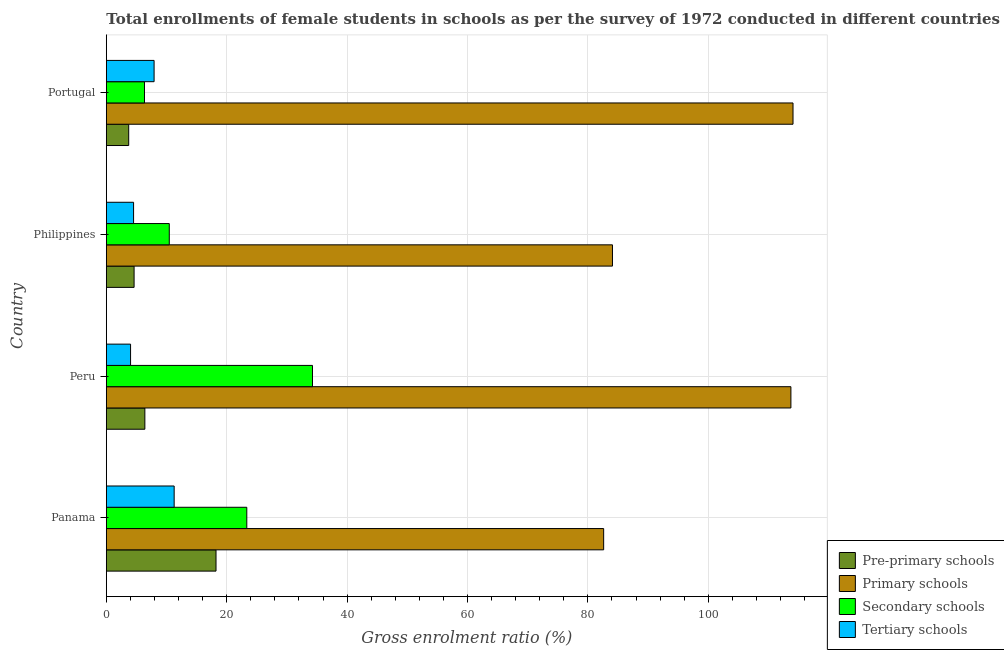Are the number of bars per tick equal to the number of legend labels?
Your answer should be compact. Yes. What is the gross enrolment ratio(female) in pre-primary schools in Philippines?
Make the answer very short. 4.61. Across all countries, what is the maximum gross enrolment ratio(female) in primary schools?
Your response must be concise. 114.07. Across all countries, what is the minimum gross enrolment ratio(female) in secondary schools?
Your answer should be very brief. 6.34. In which country was the gross enrolment ratio(female) in pre-primary schools maximum?
Provide a short and direct response. Panama. In which country was the gross enrolment ratio(female) in secondary schools minimum?
Keep it short and to the point. Portugal. What is the total gross enrolment ratio(female) in secondary schools in the graph?
Give a very brief answer. 74.37. What is the difference between the gross enrolment ratio(female) in secondary schools in Peru and that in Philippines?
Offer a terse response. 23.79. What is the difference between the gross enrolment ratio(female) in pre-primary schools in Philippines and the gross enrolment ratio(female) in secondary schools in Portugal?
Ensure brevity in your answer.  -1.73. What is the average gross enrolment ratio(female) in tertiary schools per country?
Your response must be concise. 6.94. What is the difference between the gross enrolment ratio(female) in pre-primary schools and gross enrolment ratio(female) in tertiary schools in Panama?
Give a very brief answer. 6.95. In how many countries, is the gross enrolment ratio(female) in secondary schools greater than 12 %?
Provide a succinct answer. 2. What is the ratio of the gross enrolment ratio(female) in primary schools in Peru to that in Portugal?
Provide a succinct answer. 1. Is the difference between the gross enrolment ratio(female) in pre-primary schools in Peru and Portugal greater than the difference between the gross enrolment ratio(female) in tertiary schools in Peru and Portugal?
Your answer should be very brief. Yes. What is the difference between the highest and the second highest gross enrolment ratio(female) in tertiary schools?
Offer a terse response. 3.33. What is the difference between the highest and the lowest gross enrolment ratio(female) in tertiary schools?
Offer a terse response. 7.24. What does the 4th bar from the top in Portugal represents?
Offer a very short reply. Pre-primary schools. What does the 2nd bar from the bottom in Peru represents?
Your answer should be very brief. Primary schools. How many bars are there?
Keep it short and to the point. 16. What is the difference between two consecutive major ticks on the X-axis?
Your answer should be very brief. 20. Are the values on the major ticks of X-axis written in scientific E-notation?
Your response must be concise. No. Does the graph contain grids?
Ensure brevity in your answer.  Yes. What is the title of the graph?
Your answer should be very brief. Total enrollments of female students in schools as per the survey of 1972 conducted in different countries. Does "Greece" appear as one of the legend labels in the graph?
Provide a succinct answer. No. What is the label or title of the Y-axis?
Offer a terse response. Country. What is the Gross enrolment ratio (%) of Pre-primary schools in Panama?
Offer a very short reply. 18.22. What is the Gross enrolment ratio (%) in Primary schools in Panama?
Your answer should be compact. 82.62. What is the Gross enrolment ratio (%) in Secondary schools in Panama?
Give a very brief answer. 23.33. What is the Gross enrolment ratio (%) of Tertiary schools in Panama?
Offer a very short reply. 11.27. What is the Gross enrolment ratio (%) in Pre-primary schools in Peru?
Your response must be concise. 6.4. What is the Gross enrolment ratio (%) in Primary schools in Peru?
Make the answer very short. 113.72. What is the Gross enrolment ratio (%) of Secondary schools in Peru?
Offer a very short reply. 34.25. What is the Gross enrolment ratio (%) in Tertiary schools in Peru?
Provide a short and direct response. 4.02. What is the Gross enrolment ratio (%) in Pre-primary schools in Philippines?
Keep it short and to the point. 4.61. What is the Gross enrolment ratio (%) in Primary schools in Philippines?
Give a very brief answer. 84.08. What is the Gross enrolment ratio (%) in Secondary schools in Philippines?
Make the answer very short. 10.46. What is the Gross enrolment ratio (%) in Tertiary schools in Philippines?
Your response must be concise. 4.53. What is the Gross enrolment ratio (%) in Pre-primary schools in Portugal?
Make the answer very short. 3.72. What is the Gross enrolment ratio (%) in Primary schools in Portugal?
Keep it short and to the point. 114.07. What is the Gross enrolment ratio (%) of Secondary schools in Portugal?
Your answer should be very brief. 6.34. What is the Gross enrolment ratio (%) of Tertiary schools in Portugal?
Provide a succinct answer. 7.93. Across all countries, what is the maximum Gross enrolment ratio (%) in Pre-primary schools?
Offer a terse response. 18.22. Across all countries, what is the maximum Gross enrolment ratio (%) in Primary schools?
Ensure brevity in your answer.  114.07. Across all countries, what is the maximum Gross enrolment ratio (%) in Secondary schools?
Ensure brevity in your answer.  34.25. Across all countries, what is the maximum Gross enrolment ratio (%) in Tertiary schools?
Your answer should be very brief. 11.27. Across all countries, what is the minimum Gross enrolment ratio (%) in Pre-primary schools?
Your answer should be very brief. 3.72. Across all countries, what is the minimum Gross enrolment ratio (%) in Primary schools?
Give a very brief answer. 82.62. Across all countries, what is the minimum Gross enrolment ratio (%) of Secondary schools?
Your answer should be compact. 6.34. Across all countries, what is the minimum Gross enrolment ratio (%) of Tertiary schools?
Your answer should be compact. 4.02. What is the total Gross enrolment ratio (%) of Pre-primary schools in the graph?
Offer a very short reply. 32.95. What is the total Gross enrolment ratio (%) in Primary schools in the graph?
Offer a very short reply. 394.49. What is the total Gross enrolment ratio (%) of Secondary schools in the graph?
Keep it short and to the point. 74.37. What is the total Gross enrolment ratio (%) of Tertiary schools in the graph?
Offer a terse response. 27.75. What is the difference between the Gross enrolment ratio (%) of Pre-primary schools in Panama and that in Peru?
Make the answer very short. 11.82. What is the difference between the Gross enrolment ratio (%) of Primary schools in Panama and that in Peru?
Give a very brief answer. -31.11. What is the difference between the Gross enrolment ratio (%) in Secondary schools in Panama and that in Peru?
Your response must be concise. -10.91. What is the difference between the Gross enrolment ratio (%) of Tertiary schools in Panama and that in Peru?
Your answer should be compact. 7.24. What is the difference between the Gross enrolment ratio (%) in Pre-primary schools in Panama and that in Philippines?
Make the answer very short. 13.61. What is the difference between the Gross enrolment ratio (%) of Primary schools in Panama and that in Philippines?
Make the answer very short. -1.46. What is the difference between the Gross enrolment ratio (%) of Secondary schools in Panama and that in Philippines?
Keep it short and to the point. 12.88. What is the difference between the Gross enrolment ratio (%) of Tertiary schools in Panama and that in Philippines?
Your response must be concise. 6.74. What is the difference between the Gross enrolment ratio (%) of Pre-primary schools in Panama and that in Portugal?
Your response must be concise. 14.5. What is the difference between the Gross enrolment ratio (%) of Primary schools in Panama and that in Portugal?
Make the answer very short. -31.46. What is the difference between the Gross enrolment ratio (%) of Secondary schools in Panama and that in Portugal?
Your response must be concise. 16.99. What is the difference between the Gross enrolment ratio (%) in Tertiary schools in Panama and that in Portugal?
Your answer should be very brief. 3.33. What is the difference between the Gross enrolment ratio (%) in Pre-primary schools in Peru and that in Philippines?
Provide a short and direct response. 1.79. What is the difference between the Gross enrolment ratio (%) of Primary schools in Peru and that in Philippines?
Provide a short and direct response. 29.64. What is the difference between the Gross enrolment ratio (%) of Secondary schools in Peru and that in Philippines?
Offer a very short reply. 23.79. What is the difference between the Gross enrolment ratio (%) in Tertiary schools in Peru and that in Philippines?
Provide a succinct answer. -0.5. What is the difference between the Gross enrolment ratio (%) in Pre-primary schools in Peru and that in Portugal?
Keep it short and to the point. 2.68. What is the difference between the Gross enrolment ratio (%) of Primary schools in Peru and that in Portugal?
Offer a terse response. -0.35. What is the difference between the Gross enrolment ratio (%) in Secondary schools in Peru and that in Portugal?
Keep it short and to the point. 27.91. What is the difference between the Gross enrolment ratio (%) in Tertiary schools in Peru and that in Portugal?
Your answer should be compact. -3.91. What is the difference between the Gross enrolment ratio (%) of Pre-primary schools in Philippines and that in Portugal?
Your response must be concise. 0.89. What is the difference between the Gross enrolment ratio (%) of Primary schools in Philippines and that in Portugal?
Provide a short and direct response. -29.99. What is the difference between the Gross enrolment ratio (%) in Secondary schools in Philippines and that in Portugal?
Your answer should be compact. 4.12. What is the difference between the Gross enrolment ratio (%) of Tertiary schools in Philippines and that in Portugal?
Offer a terse response. -3.41. What is the difference between the Gross enrolment ratio (%) of Pre-primary schools in Panama and the Gross enrolment ratio (%) of Primary schools in Peru?
Your answer should be very brief. -95.5. What is the difference between the Gross enrolment ratio (%) of Pre-primary schools in Panama and the Gross enrolment ratio (%) of Secondary schools in Peru?
Your answer should be compact. -16.02. What is the difference between the Gross enrolment ratio (%) of Pre-primary schools in Panama and the Gross enrolment ratio (%) of Tertiary schools in Peru?
Ensure brevity in your answer.  14.2. What is the difference between the Gross enrolment ratio (%) of Primary schools in Panama and the Gross enrolment ratio (%) of Secondary schools in Peru?
Keep it short and to the point. 48.37. What is the difference between the Gross enrolment ratio (%) in Primary schools in Panama and the Gross enrolment ratio (%) in Tertiary schools in Peru?
Provide a succinct answer. 78.59. What is the difference between the Gross enrolment ratio (%) in Secondary schools in Panama and the Gross enrolment ratio (%) in Tertiary schools in Peru?
Give a very brief answer. 19.31. What is the difference between the Gross enrolment ratio (%) in Pre-primary schools in Panama and the Gross enrolment ratio (%) in Primary schools in Philippines?
Your response must be concise. -65.86. What is the difference between the Gross enrolment ratio (%) in Pre-primary schools in Panama and the Gross enrolment ratio (%) in Secondary schools in Philippines?
Provide a succinct answer. 7.76. What is the difference between the Gross enrolment ratio (%) in Pre-primary schools in Panama and the Gross enrolment ratio (%) in Tertiary schools in Philippines?
Make the answer very short. 13.7. What is the difference between the Gross enrolment ratio (%) of Primary schools in Panama and the Gross enrolment ratio (%) of Secondary schools in Philippines?
Give a very brief answer. 72.16. What is the difference between the Gross enrolment ratio (%) in Primary schools in Panama and the Gross enrolment ratio (%) in Tertiary schools in Philippines?
Your response must be concise. 78.09. What is the difference between the Gross enrolment ratio (%) in Secondary schools in Panama and the Gross enrolment ratio (%) in Tertiary schools in Philippines?
Your response must be concise. 18.81. What is the difference between the Gross enrolment ratio (%) in Pre-primary schools in Panama and the Gross enrolment ratio (%) in Primary schools in Portugal?
Ensure brevity in your answer.  -95.85. What is the difference between the Gross enrolment ratio (%) in Pre-primary schools in Panama and the Gross enrolment ratio (%) in Secondary schools in Portugal?
Offer a very short reply. 11.88. What is the difference between the Gross enrolment ratio (%) of Pre-primary schools in Panama and the Gross enrolment ratio (%) of Tertiary schools in Portugal?
Your answer should be very brief. 10.29. What is the difference between the Gross enrolment ratio (%) in Primary schools in Panama and the Gross enrolment ratio (%) in Secondary schools in Portugal?
Make the answer very short. 76.28. What is the difference between the Gross enrolment ratio (%) of Primary schools in Panama and the Gross enrolment ratio (%) of Tertiary schools in Portugal?
Give a very brief answer. 74.68. What is the difference between the Gross enrolment ratio (%) in Secondary schools in Panama and the Gross enrolment ratio (%) in Tertiary schools in Portugal?
Offer a terse response. 15.4. What is the difference between the Gross enrolment ratio (%) in Pre-primary schools in Peru and the Gross enrolment ratio (%) in Primary schools in Philippines?
Keep it short and to the point. -77.68. What is the difference between the Gross enrolment ratio (%) in Pre-primary schools in Peru and the Gross enrolment ratio (%) in Secondary schools in Philippines?
Provide a succinct answer. -4.06. What is the difference between the Gross enrolment ratio (%) in Pre-primary schools in Peru and the Gross enrolment ratio (%) in Tertiary schools in Philippines?
Provide a succinct answer. 1.87. What is the difference between the Gross enrolment ratio (%) of Primary schools in Peru and the Gross enrolment ratio (%) of Secondary schools in Philippines?
Your answer should be compact. 103.27. What is the difference between the Gross enrolment ratio (%) in Primary schools in Peru and the Gross enrolment ratio (%) in Tertiary schools in Philippines?
Your answer should be very brief. 109.2. What is the difference between the Gross enrolment ratio (%) in Secondary schools in Peru and the Gross enrolment ratio (%) in Tertiary schools in Philippines?
Provide a succinct answer. 29.72. What is the difference between the Gross enrolment ratio (%) of Pre-primary schools in Peru and the Gross enrolment ratio (%) of Primary schools in Portugal?
Your answer should be very brief. -107.67. What is the difference between the Gross enrolment ratio (%) in Pre-primary schools in Peru and the Gross enrolment ratio (%) in Secondary schools in Portugal?
Provide a succinct answer. 0.06. What is the difference between the Gross enrolment ratio (%) in Pre-primary schools in Peru and the Gross enrolment ratio (%) in Tertiary schools in Portugal?
Offer a terse response. -1.53. What is the difference between the Gross enrolment ratio (%) in Primary schools in Peru and the Gross enrolment ratio (%) in Secondary schools in Portugal?
Your response must be concise. 107.38. What is the difference between the Gross enrolment ratio (%) of Primary schools in Peru and the Gross enrolment ratio (%) of Tertiary schools in Portugal?
Your answer should be compact. 105.79. What is the difference between the Gross enrolment ratio (%) of Secondary schools in Peru and the Gross enrolment ratio (%) of Tertiary schools in Portugal?
Give a very brief answer. 26.31. What is the difference between the Gross enrolment ratio (%) of Pre-primary schools in Philippines and the Gross enrolment ratio (%) of Primary schools in Portugal?
Offer a terse response. -109.46. What is the difference between the Gross enrolment ratio (%) of Pre-primary schools in Philippines and the Gross enrolment ratio (%) of Secondary schools in Portugal?
Ensure brevity in your answer.  -1.73. What is the difference between the Gross enrolment ratio (%) in Pre-primary schools in Philippines and the Gross enrolment ratio (%) in Tertiary schools in Portugal?
Make the answer very short. -3.32. What is the difference between the Gross enrolment ratio (%) of Primary schools in Philippines and the Gross enrolment ratio (%) of Secondary schools in Portugal?
Offer a terse response. 77.74. What is the difference between the Gross enrolment ratio (%) of Primary schools in Philippines and the Gross enrolment ratio (%) of Tertiary schools in Portugal?
Offer a terse response. 76.15. What is the difference between the Gross enrolment ratio (%) in Secondary schools in Philippines and the Gross enrolment ratio (%) in Tertiary schools in Portugal?
Make the answer very short. 2.52. What is the average Gross enrolment ratio (%) of Pre-primary schools per country?
Ensure brevity in your answer.  8.24. What is the average Gross enrolment ratio (%) in Primary schools per country?
Provide a succinct answer. 98.62. What is the average Gross enrolment ratio (%) in Secondary schools per country?
Your answer should be very brief. 18.59. What is the average Gross enrolment ratio (%) in Tertiary schools per country?
Offer a very short reply. 6.94. What is the difference between the Gross enrolment ratio (%) of Pre-primary schools and Gross enrolment ratio (%) of Primary schools in Panama?
Keep it short and to the point. -64.4. What is the difference between the Gross enrolment ratio (%) in Pre-primary schools and Gross enrolment ratio (%) in Secondary schools in Panama?
Provide a short and direct response. -5.11. What is the difference between the Gross enrolment ratio (%) of Pre-primary schools and Gross enrolment ratio (%) of Tertiary schools in Panama?
Your answer should be very brief. 6.95. What is the difference between the Gross enrolment ratio (%) of Primary schools and Gross enrolment ratio (%) of Secondary schools in Panama?
Provide a short and direct response. 59.28. What is the difference between the Gross enrolment ratio (%) in Primary schools and Gross enrolment ratio (%) in Tertiary schools in Panama?
Offer a terse response. 71.35. What is the difference between the Gross enrolment ratio (%) of Secondary schools and Gross enrolment ratio (%) of Tertiary schools in Panama?
Provide a short and direct response. 12.07. What is the difference between the Gross enrolment ratio (%) in Pre-primary schools and Gross enrolment ratio (%) in Primary schools in Peru?
Offer a very short reply. -107.32. What is the difference between the Gross enrolment ratio (%) of Pre-primary schools and Gross enrolment ratio (%) of Secondary schools in Peru?
Your answer should be compact. -27.85. What is the difference between the Gross enrolment ratio (%) of Pre-primary schools and Gross enrolment ratio (%) of Tertiary schools in Peru?
Provide a short and direct response. 2.38. What is the difference between the Gross enrolment ratio (%) of Primary schools and Gross enrolment ratio (%) of Secondary schools in Peru?
Make the answer very short. 79.48. What is the difference between the Gross enrolment ratio (%) in Primary schools and Gross enrolment ratio (%) in Tertiary schools in Peru?
Provide a short and direct response. 109.7. What is the difference between the Gross enrolment ratio (%) in Secondary schools and Gross enrolment ratio (%) in Tertiary schools in Peru?
Offer a terse response. 30.22. What is the difference between the Gross enrolment ratio (%) in Pre-primary schools and Gross enrolment ratio (%) in Primary schools in Philippines?
Offer a very short reply. -79.47. What is the difference between the Gross enrolment ratio (%) in Pre-primary schools and Gross enrolment ratio (%) in Secondary schools in Philippines?
Ensure brevity in your answer.  -5.85. What is the difference between the Gross enrolment ratio (%) in Pre-primary schools and Gross enrolment ratio (%) in Tertiary schools in Philippines?
Ensure brevity in your answer.  0.08. What is the difference between the Gross enrolment ratio (%) of Primary schools and Gross enrolment ratio (%) of Secondary schools in Philippines?
Your answer should be compact. 73.62. What is the difference between the Gross enrolment ratio (%) of Primary schools and Gross enrolment ratio (%) of Tertiary schools in Philippines?
Provide a succinct answer. 79.55. What is the difference between the Gross enrolment ratio (%) in Secondary schools and Gross enrolment ratio (%) in Tertiary schools in Philippines?
Provide a short and direct response. 5.93. What is the difference between the Gross enrolment ratio (%) in Pre-primary schools and Gross enrolment ratio (%) in Primary schools in Portugal?
Provide a short and direct response. -110.36. What is the difference between the Gross enrolment ratio (%) in Pre-primary schools and Gross enrolment ratio (%) in Secondary schools in Portugal?
Provide a succinct answer. -2.62. What is the difference between the Gross enrolment ratio (%) of Pre-primary schools and Gross enrolment ratio (%) of Tertiary schools in Portugal?
Make the answer very short. -4.22. What is the difference between the Gross enrolment ratio (%) of Primary schools and Gross enrolment ratio (%) of Secondary schools in Portugal?
Ensure brevity in your answer.  107.73. What is the difference between the Gross enrolment ratio (%) of Primary schools and Gross enrolment ratio (%) of Tertiary schools in Portugal?
Ensure brevity in your answer.  106.14. What is the difference between the Gross enrolment ratio (%) of Secondary schools and Gross enrolment ratio (%) of Tertiary schools in Portugal?
Make the answer very short. -1.6. What is the ratio of the Gross enrolment ratio (%) of Pre-primary schools in Panama to that in Peru?
Your response must be concise. 2.85. What is the ratio of the Gross enrolment ratio (%) in Primary schools in Panama to that in Peru?
Offer a terse response. 0.73. What is the ratio of the Gross enrolment ratio (%) of Secondary schools in Panama to that in Peru?
Provide a short and direct response. 0.68. What is the ratio of the Gross enrolment ratio (%) in Tertiary schools in Panama to that in Peru?
Offer a terse response. 2.8. What is the ratio of the Gross enrolment ratio (%) in Pre-primary schools in Panama to that in Philippines?
Provide a short and direct response. 3.95. What is the ratio of the Gross enrolment ratio (%) of Primary schools in Panama to that in Philippines?
Offer a terse response. 0.98. What is the ratio of the Gross enrolment ratio (%) in Secondary schools in Panama to that in Philippines?
Provide a short and direct response. 2.23. What is the ratio of the Gross enrolment ratio (%) in Tertiary schools in Panama to that in Philippines?
Your answer should be very brief. 2.49. What is the ratio of the Gross enrolment ratio (%) in Pre-primary schools in Panama to that in Portugal?
Offer a very short reply. 4.9. What is the ratio of the Gross enrolment ratio (%) of Primary schools in Panama to that in Portugal?
Your answer should be compact. 0.72. What is the ratio of the Gross enrolment ratio (%) of Secondary schools in Panama to that in Portugal?
Ensure brevity in your answer.  3.68. What is the ratio of the Gross enrolment ratio (%) of Tertiary schools in Panama to that in Portugal?
Make the answer very short. 1.42. What is the ratio of the Gross enrolment ratio (%) of Pre-primary schools in Peru to that in Philippines?
Offer a very short reply. 1.39. What is the ratio of the Gross enrolment ratio (%) of Primary schools in Peru to that in Philippines?
Provide a short and direct response. 1.35. What is the ratio of the Gross enrolment ratio (%) in Secondary schools in Peru to that in Philippines?
Ensure brevity in your answer.  3.27. What is the ratio of the Gross enrolment ratio (%) in Tertiary schools in Peru to that in Philippines?
Offer a terse response. 0.89. What is the ratio of the Gross enrolment ratio (%) in Pre-primary schools in Peru to that in Portugal?
Make the answer very short. 1.72. What is the ratio of the Gross enrolment ratio (%) of Primary schools in Peru to that in Portugal?
Provide a short and direct response. 1. What is the ratio of the Gross enrolment ratio (%) of Secondary schools in Peru to that in Portugal?
Offer a terse response. 5.4. What is the ratio of the Gross enrolment ratio (%) of Tertiary schools in Peru to that in Portugal?
Give a very brief answer. 0.51. What is the ratio of the Gross enrolment ratio (%) in Pre-primary schools in Philippines to that in Portugal?
Give a very brief answer. 1.24. What is the ratio of the Gross enrolment ratio (%) in Primary schools in Philippines to that in Portugal?
Offer a very short reply. 0.74. What is the ratio of the Gross enrolment ratio (%) of Secondary schools in Philippines to that in Portugal?
Your response must be concise. 1.65. What is the ratio of the Gross enrolment ratio (%) of Tertiary schools in Philippines to that in Portugal?
Your response must be concise. 0.57. What is the difference between the highest and the second highest Gross enrolment ratio (%) of Pre-primary schools?
Your answer should be compact. 11.82. What is the difference between the highest and the second highest Gross enrolment ratio (%) in Primary schools?
Ensure brevity in your answer.  0.35. What is the difference between the highest and the second highest Gross enrolment ratio (%) in Secondary schools?
Offer a very short reply. 10.91. What is the difference between the highest and the second highest Gross enrolment ratio (%) of Tertiary schools?
Provide a short and direct response. 3.33. What is the difference between the highest and the lowest Gross enrolment ratio (%) of Pre-primary schools?
Your response must be concise. 14.5. What is the difference between the highest and the lowest Gross enrolment ratio (%) in Primary schools?
Provide a short and direct response. 31.46. What is the difference between the highest and the lowest Gross enrolment ratio (%) in Secondary schools?
Keep it short and to the point. 27.91. What is the difference between the highest and the lowest Gross enrolment ratio (%) in Tertiary schools?
Give a very brief answer. 7.24. 